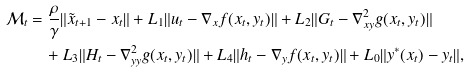Convert formula to latex. <formula><loc_0><loc_0><loc_500><loc_500>\mathcal { M } _ { t } & = \frac { \rho } { \gamma } \| \tilde { x } _ { t + 1 } - x _ { t } \| + L _ { 1 } \| u _ { t } - \nabla _ { x } f ( x _ { t } , y _ { t } ) \| + L _ { 2 } \| G _ { t } - \nabla ^ { 2 } _ { x y } g ( x _ { t } , y _ { t } ) \| \\ & \quad + L _ { 3 } \| H _ { t } - \nabla ^ { 2 } _ { y y } g ( x _ { t } , y _ { t } ) \| + L _ { 4 } \| h _ { t } - \nabla _ { y } f ( x _ { t } , y _ { t } ) \| + L _ { 0 } \| y ^ { * } ( x _ { t } ) - y _ { t } \| ,</formula> 